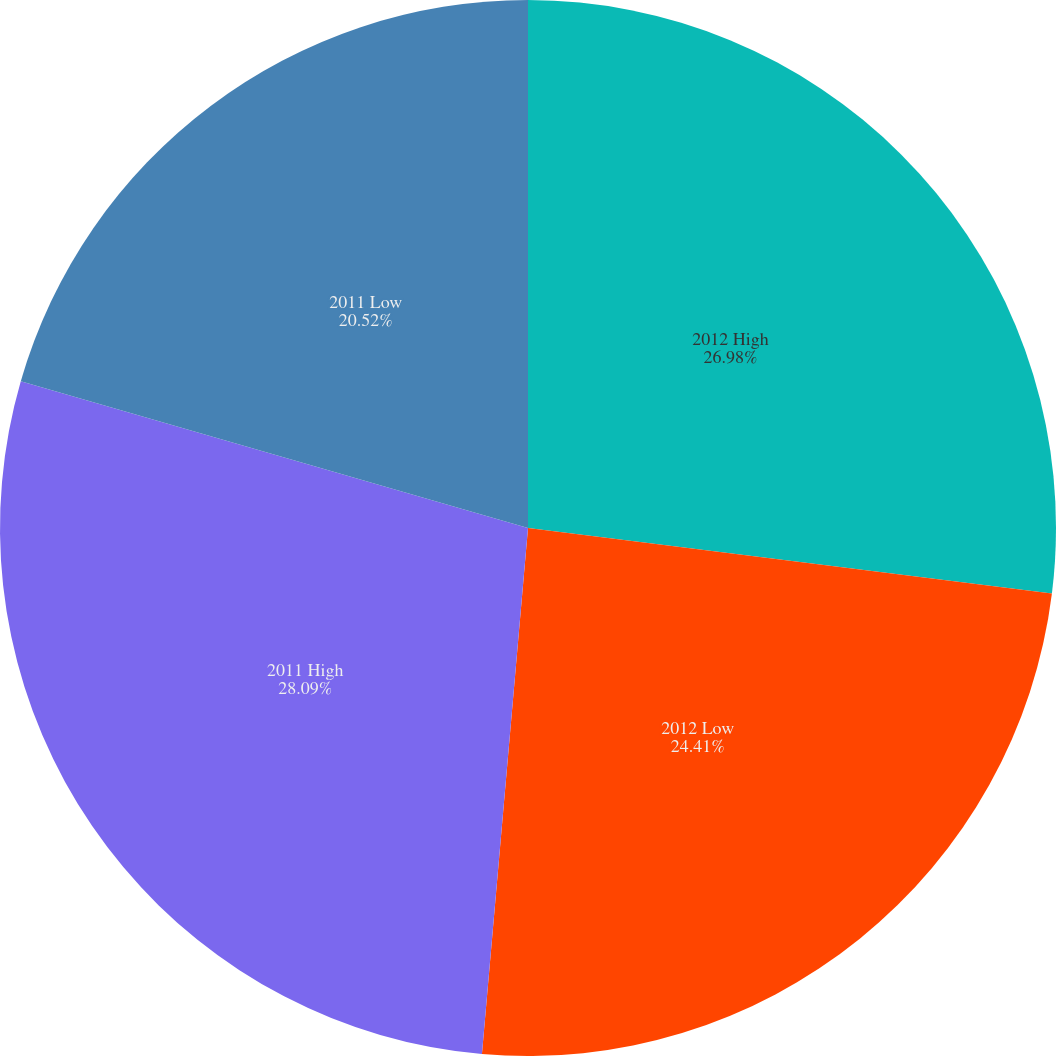<chart> <loc_0><loc_0><loc_500><loc_500><pie_chart><fcel>2012 High<fcel>2012 Low<fcel>2011 High<fcel>2011 Low<nl><fcel>26.98%<fcel>24.41%<fcel>28.09%<fcel>20.52%<nl></chart> 